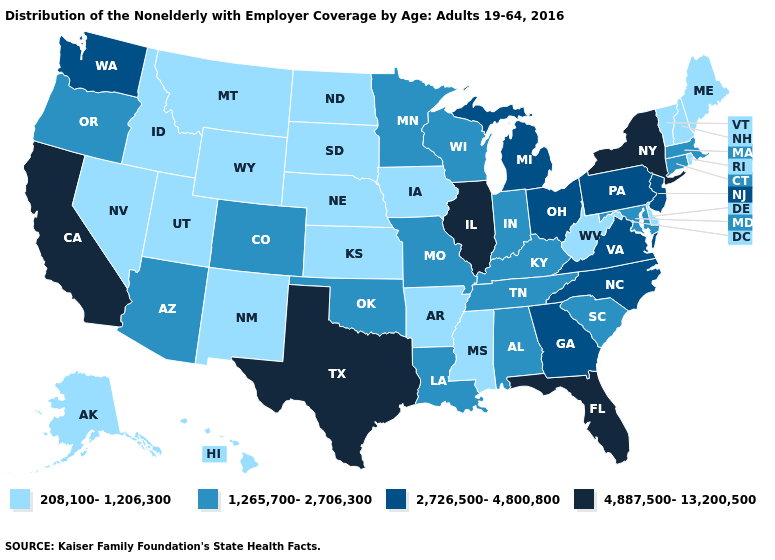Among the states that border Colorado , which have the lowest value?
Give a very brief answer. Kansas, Nebraska, New Mexico, Utah, Wyoming. What is the value of Connecticut?
Write a very short answer. 1,265,700-2,706,300. What is the value of Tennessee?
Give a very brief answer. 1,265,700-2,706,300. Which states have the lowest value in the USA?
Short answer required. Alaska, Arkansas, Delaware, Hawaii, Idaho, Iowa, Kansas, Maine, Mississippi, Montana, Nebraska, Nevada, New Hampshire, New Mexico, North Dakota, Rhode Island, South Dakota, Utah, Vermont, West Virginia, Wyoming. Name the states that have a value in the range 208,100-1,206,300?
Quick response, please. Alaska, Arkansas, Delaware, Hawaii, Idaho, Iowa, Kansas, Maine, Mississippi, Montana, Nebraska, Nevada, New Hampshire, New Mexico, North Dakota, Rhode Island, South Dakota, Utah, Vermont, West Virginia, Wyoming. Name the states that have a value in the range 1,265,700-2,706,300?
Answer briefly. Alabama, Arizona, Colorado, Connecticut, Indiana, Kentucky, Louisiana, Maryland, Massachusetts, Minnesota, Missouri, Oklahoma, Oregon, South Carolina, Tennessee, Wisconsin. What is the value of Ohio?
Write a very short answer. 2,726,500-4,800,800. Among the states that border Maryland , does Delaware have the lowest value?
Short answer required. Yes. Does New Hampshire have a lower value than Colorado?
Answer briefly. Yes. Name the states that have a value in the range 1,265,700-2,706,300?
Keep it brief. Alabama, Arizona, Colorado, Connecticut, Indiana, Kentucky, Louisiana, Maryland, Massachusetts, Minnesota, Missouri, Oklahoma, Oregon, South Carolina, Tennessee, Wisconsin. Which states hav the highest value in the Northeast?
Answer briefly. New York. Which states have the lowest value in the USA?
Give a very brief answer. Alaska, Arkansas, Delaware, Hawaii, Idaho, Iowa, Kansas, Maine, Mississippi, Montana, Nebraska, Nevada, New Hampshire, New Mexico, North Dakota, Rhode Island, South Dakota, Utah, Vermont, West Virginia, Wyoming. Which states have the lowest value in the MidWest?
Quick response, please. Iowa, Kansas, Nebraska, North Dakota, South Dakota. What is the value of Wyoming?
Be succinct. 208,100-1,206,300. Does the map have missing data?
Write a very short answer. No. 